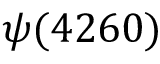<formula> <loc_0><loc_0><loc_500><loc_500>\psi ( 4 2 6 0 )</formula> 